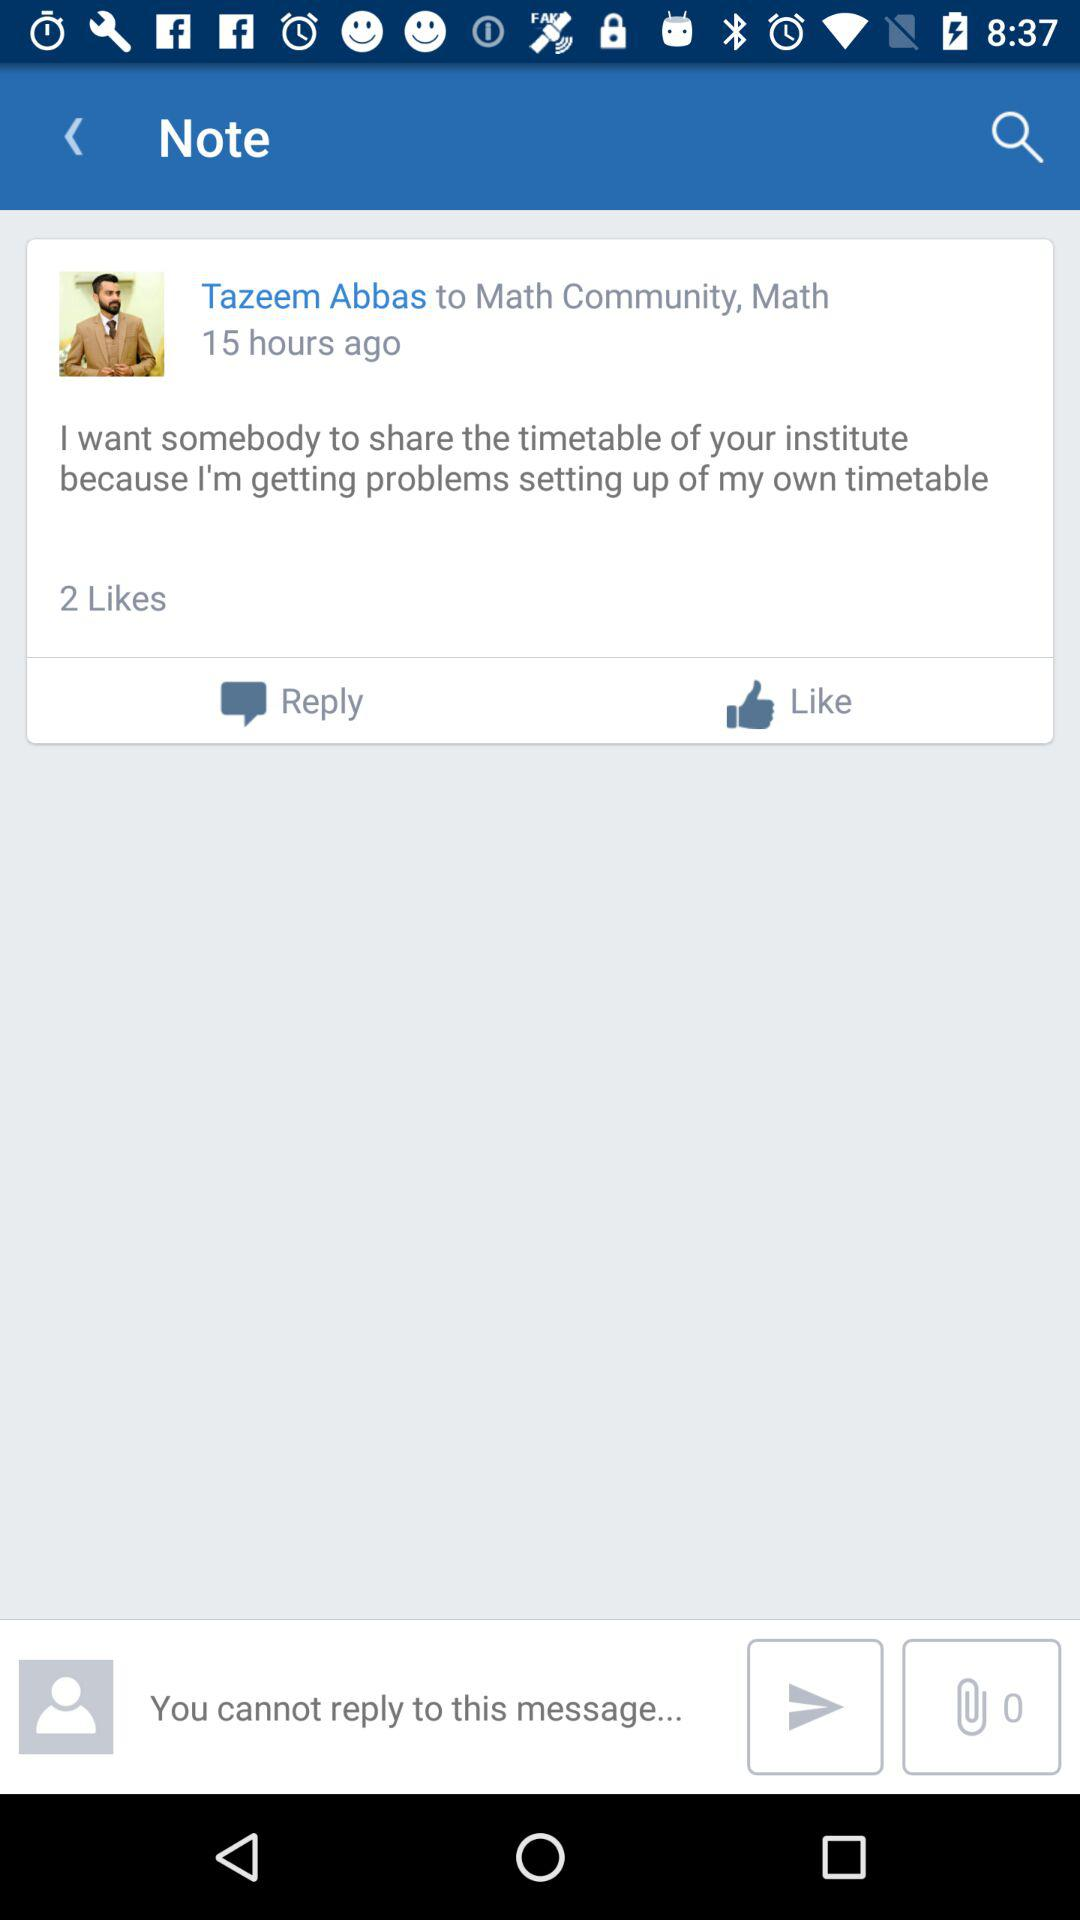How many likes are there on the note?
Answer the question using a single word or phrase. 2 